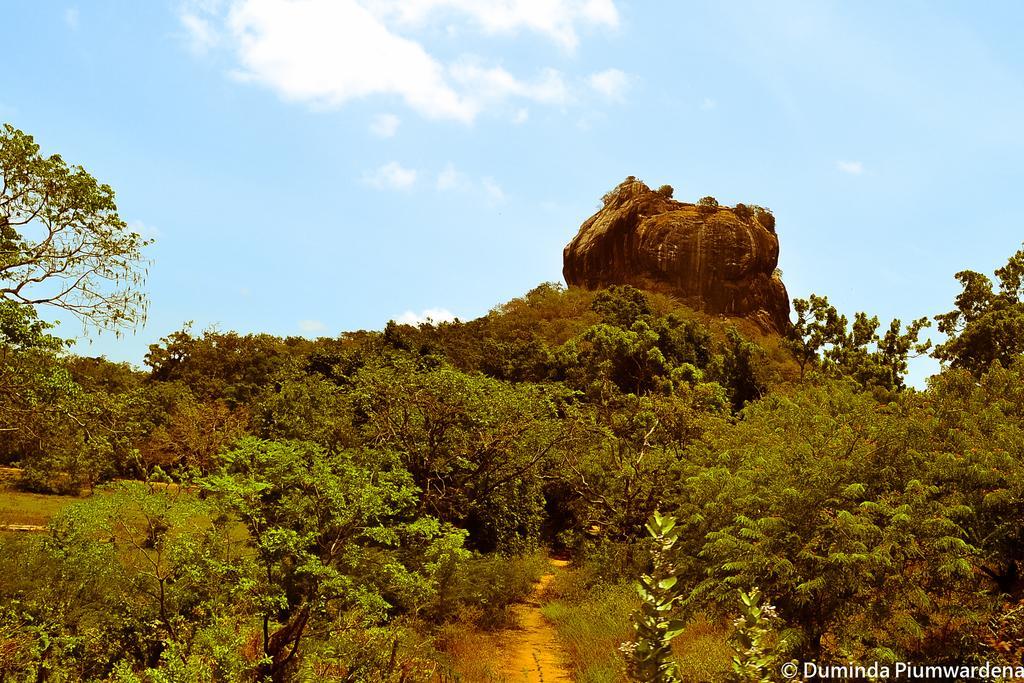Can you describe this image briefly? This is an outside view. At the bottom there is a path. On the both sides there are many trees. In the background there is a rock. At the top of the image I can see the sky and clouds. 